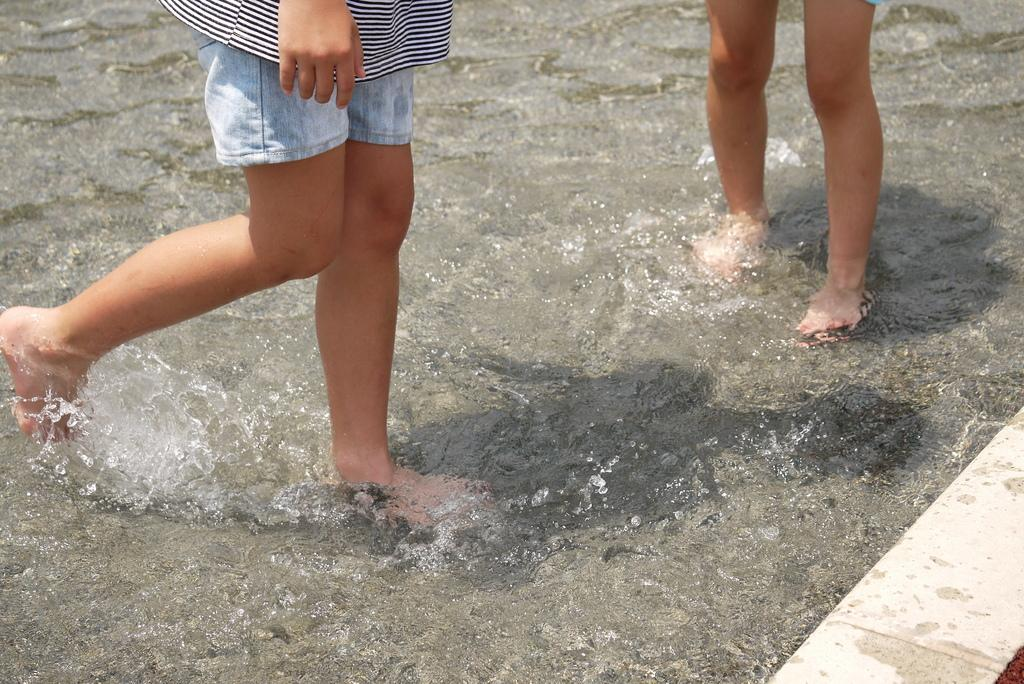What are the humans in the image doing? The humans in the image are in the water. Can you describe any visible body parts of the humans? Their legs are visible in the image. Are there any other body parts visible besides the legs? Yes, a hand is visible in the image. What type of floor can be seen under the water in the image? There is no floor visible under the water in the image, as it is focused on the humans in the water. 